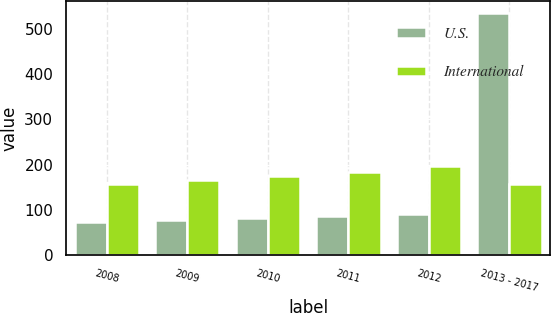Convert chart to OTSL. <chart><loc_0><loc_0><loc_500><loc_500><stacked_bar_chart><ecel><fcel>2008<fcel>2009<fcel>2010<fcel>2011<fcel>2012<fcel>2013 - 2017<nl><fcel>U.S.<fcel>74<fcel>77<fcel>82<fcel>86<fcel>90<fcel>536<nl><fcel>International<fcel>157<fcel>166<fcel>175<fcel>184<fcel>197<fcel>157<nl></chart> 